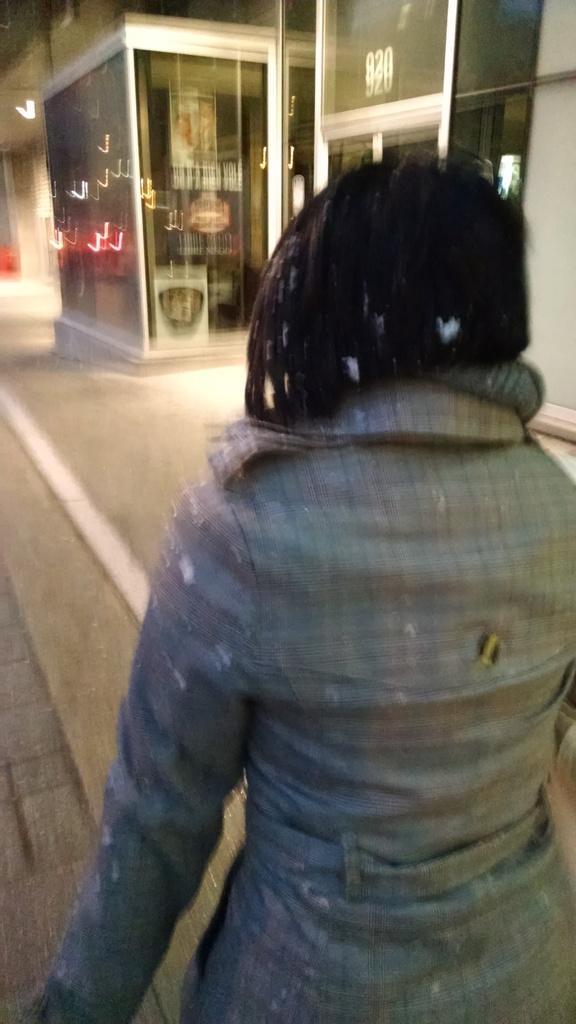In one or two sentences, can you explain what this image depicts? In this image we can see a woman, there is a store with some objects in it and also we can see a building. 